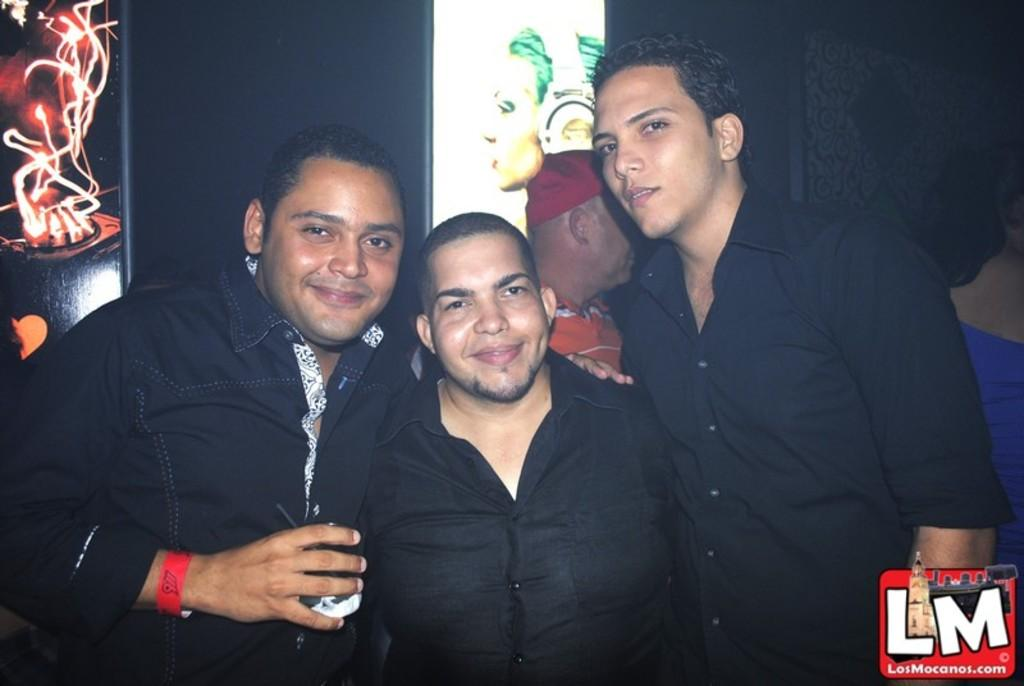How many friends are in the image? There are three friends in the image. What are the friends wearing? The friends are wearing black shirts. What expression do the friends have? The friends are smiling. What are the friends doing in the image? The friends are posing for the camera. What can be seen in the background of the image? There is a black wall in the background. What is on the wall in the background? There is a photo frame on the wall. Can you see any signs or the ocean in the image? No, there are no signs or ocean visible in the image. Is there a cow present in the image? No, there is no cow present in the image. 